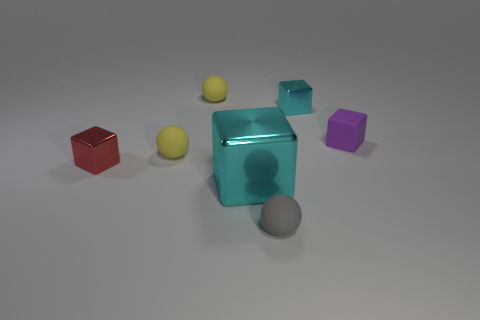Add 1 yellow balls. How many objects exist? 8 Subtract all cubes. How many objects are left? 3 Subtract all small gray metal cylinders. Subtract all tiny matte cubes. How many objects are left? 6 Add 4 gray rubber spheres. How many gray rubber spheres are left? 5 Add 6 tiny purple objects. How many tiny purple objects exist? 7 Subtract 0 cyan spheres. How many objects are left? 7 